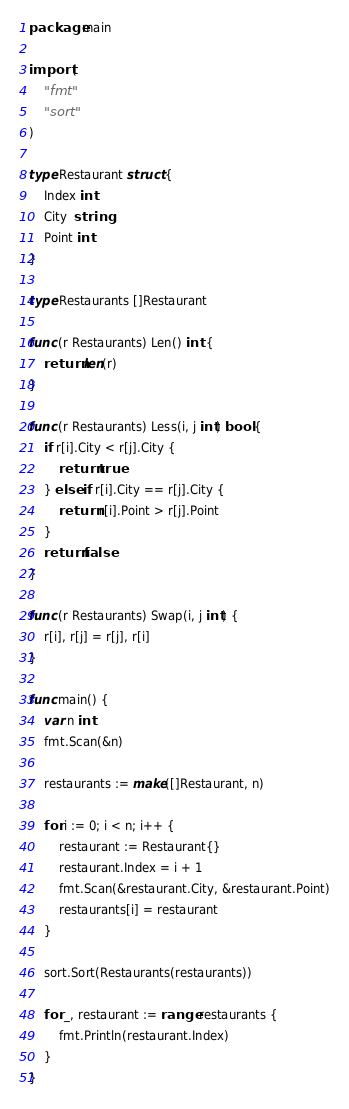Convert code to text. <code><loc_0><loc_0><loc_500><loc_500><_Go_>package main

import (
	"fmt"
	"sort"
)

type Restaurant struct {
	Index int
	City  string
	Point int
}

type Restaurants []Restaurant

func (r Restaurants) Len() int {
	return len(r)
}

func (r Restaurants) Less(i, j int) bool {
	if r[i].City < r[j].City {
		return true
	} else if r[i].City == r[j].City {
		return r[i].Point > r[j].Point
	}
	return false
}

func (r Restaurants) Swap(i, j int) {
	r[i], r[j] = r[j], r[i]
}

func main() {
	var n int
	fmt.Scan(&n)

	restaurants := make([]Restaurant, n)

	for i := 0; i < n; i++ {
		restaurant := Restaurant{}
		restaurant.Index = i + 1
		fmt.Scan(&restaurant.City, &restaurant.Point)
		restaurants[i] = restaurant
	}

	sort.Sort(Restaurants(restaurants))

	for _, restaurant := range restaurants {
		fmt.Println(restaurant.Index)
	}
}
</code> 